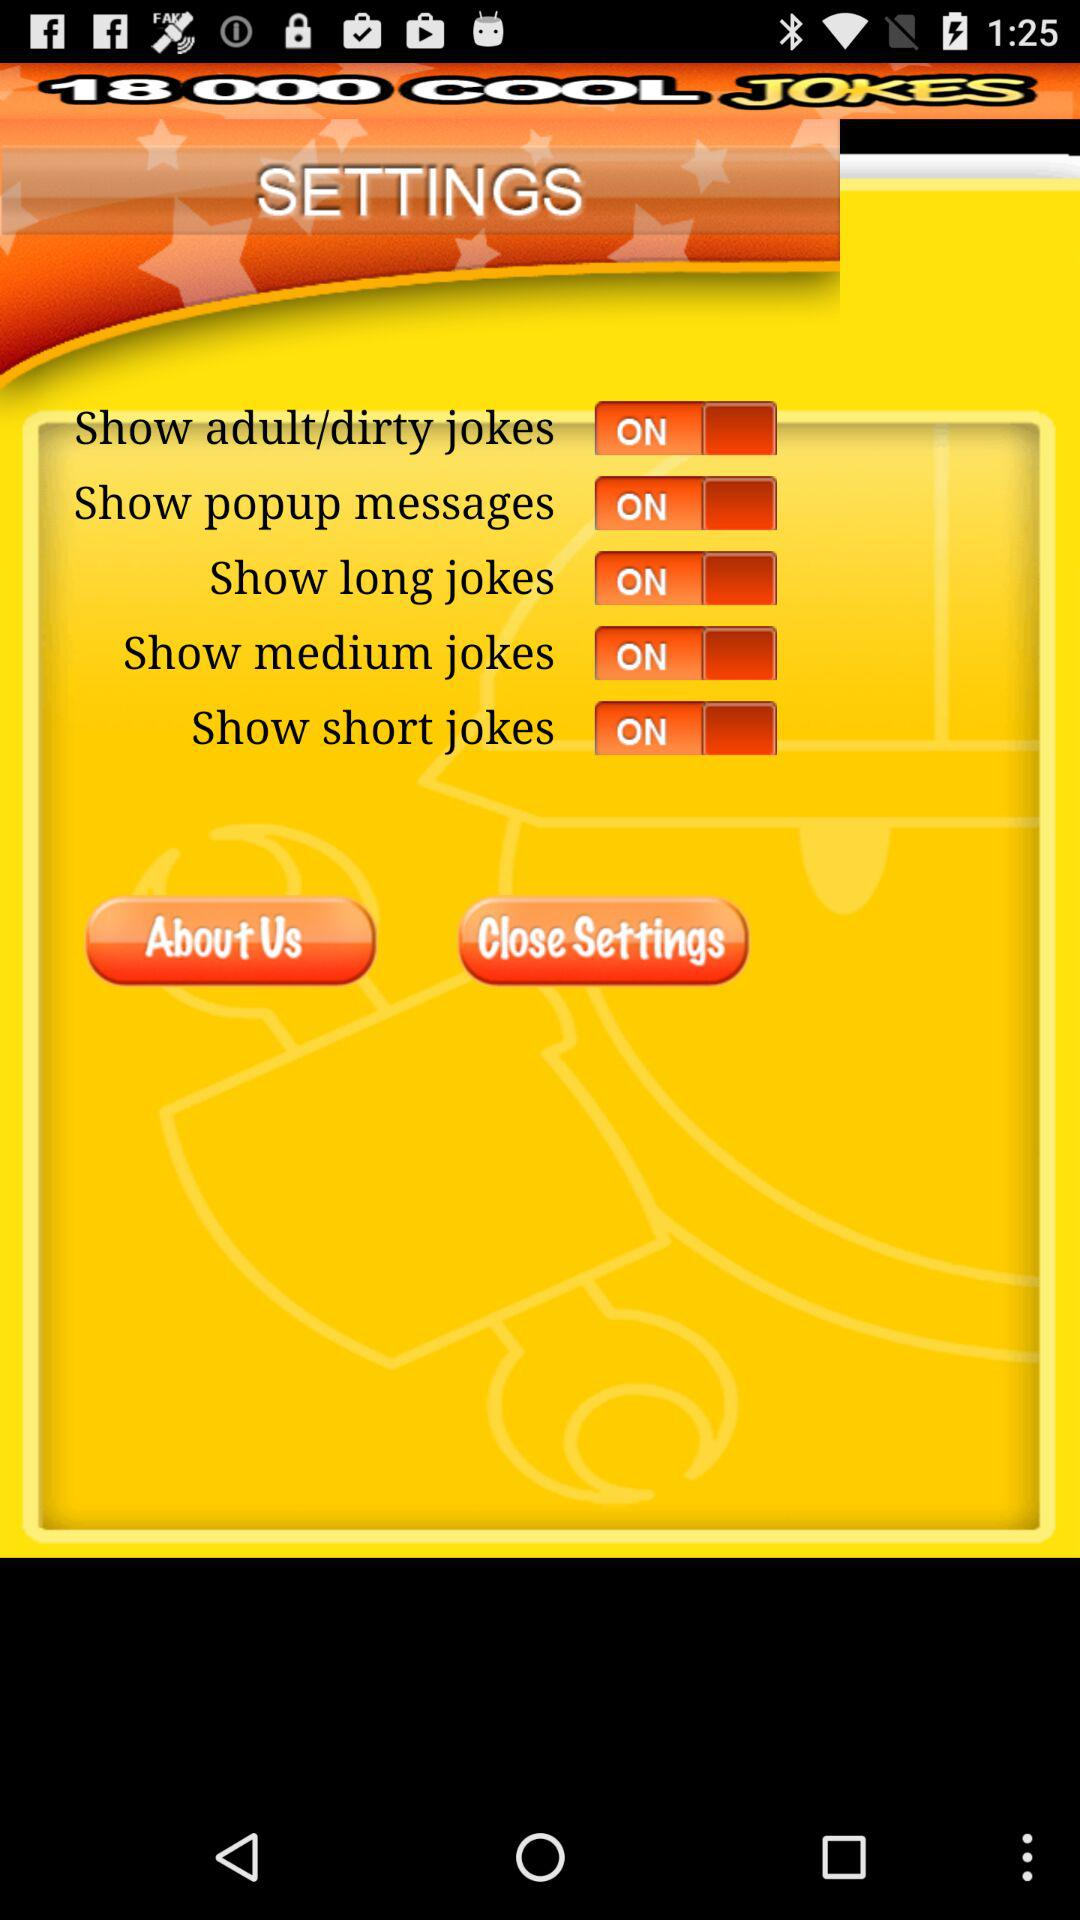Which settings options are turned on? The settings options that are turned on are "Show adult/dirty jokes", "Show popup messages", "Show long jokes", "Show medium jokes" and "Show short jokes". 